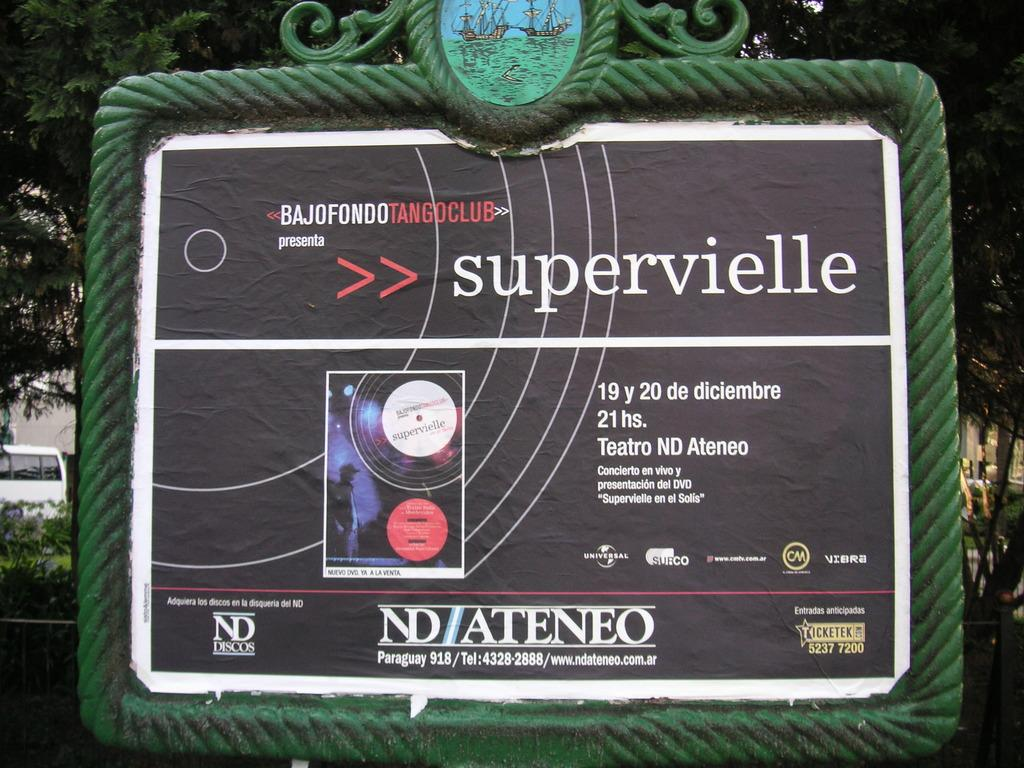What is the main object in the center of the image? There is a board in the center of the image. What can be seen on the left side of the image? There is a vehicle on the left side of the image. What type of natural scenery is visible in the background of the image? There are trees visible in the background of the image. Where is the tray located in the image? There is no tray present in the image. What type of activity is taking place in the lunchroom in the image? There is no lunchroom or activity present in the image. 